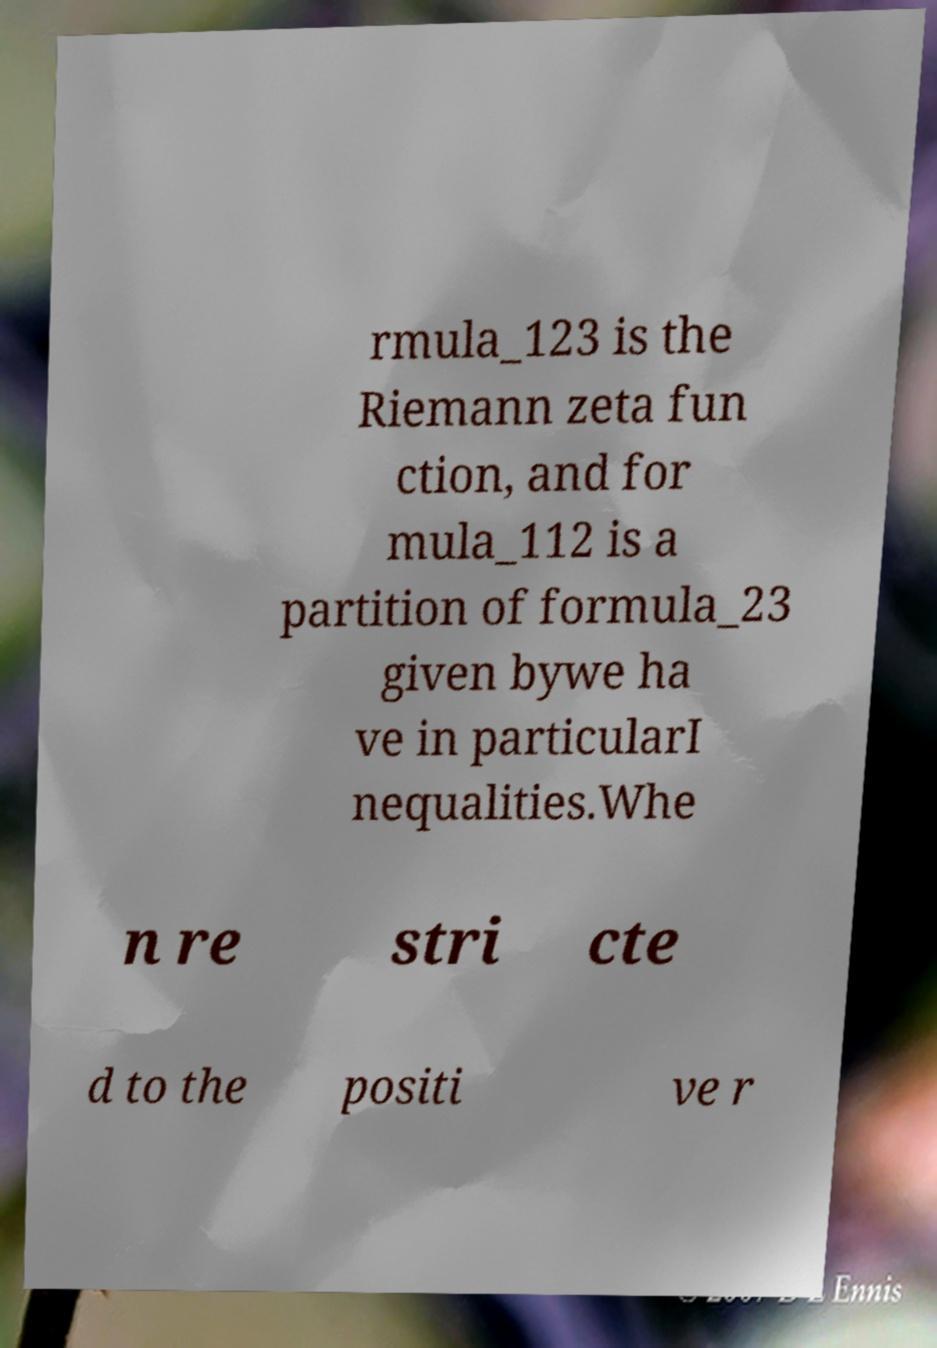For documentation purposes, I need the text within this image transcribed. Could you provide that? rmula_123 is the Riemann zeta fun ction, and for mula_112 is a partition of formula_23 given bywe ha ve in particularI nequalities.Whe n re stri cte d to the positi ve r 